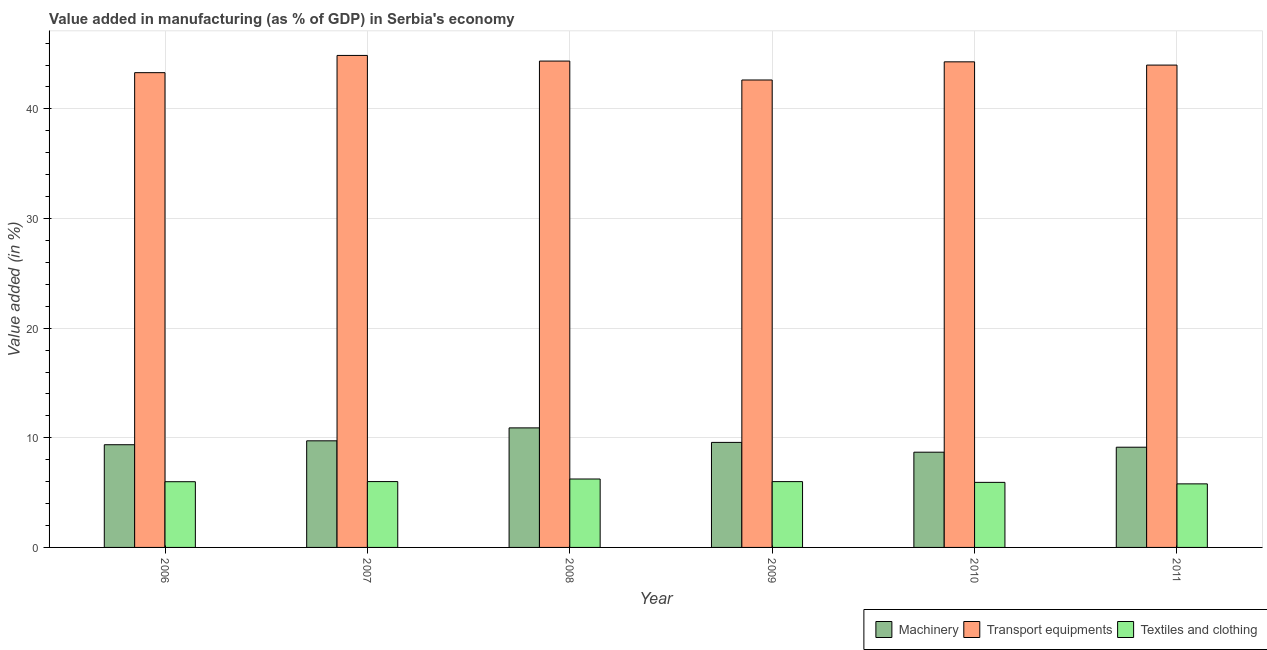How many different coloured bars are there?
Ensure brevity in your answer.  3. How many groups of bars are there?
Give a very brief answer. 6. In how many cases, is the number of bars for a given year not equal to the number of legend labels?
Offer a terse response. 0. What is the value added in manufacturing textile and clothing in 2006?
Your answer should be very brief. 6. Across all years, what is the maximum value added in manufacturing textile and clothing?
Your answer should be very brief. 6.24. Across all years, what is the minimum value added in manufacturing textile and clothing?
Offer a terse response. 5.8. In which year was the value added in manufacturing machinery maximum?
Make the answer very short. 2008. What is the total value added in manufacturing textile and clothing in the graph?
Your response must be concise. 35.98. What is the difference between the value added in manufacturing textile and clothing in 2006 and that in 2011?
Keep it short and to the point. 0.2. What is the difference between the value added in manufacturing transport equipments in 2006 and the value added in manufacturing textile and clothing in 2008?
Ensure brevity in your answer.  -1.06. What is the average value added in manufacturing textile and clothing per year?
Provide a succinct answer. 6. What is the ratio of the value added in manufacturing textile and clothing in 2010 to that in 2011?
Provide a succinct answer. 1.02. Is the difference between the value added in manufacturing textile and clothing in 2008 and 2011 greater than the difference between the value added in manufacturing machinery in 2008 and 2011?
Ensure brevity in your answer.  No. What is the difference between the highest and the second highest value added in manufacturing machinery?
Make the answer very short. 1.18. What is the difference between the highest and the lowest value added in manufacturing textile and clothing?
Give a very brief answer. 0.44. In how many years, is the value added in manufacturing textile and clothing greater than the average value added in manufacturing textile and clothing taken over all years?
Your response must be concise. 3. What does the 1st bar from the left in 2008 represents?
Make the answer very short. Machinery. What does the 3rd bar from the right in 2008 represents?
Give a very brief answer. Machinery. Is it the case that in every year, the sum of the value added in manufacturing machinery and value added in manufacturing transport equipments is greater than the value added in manufacturing textile and clothing?
Your answer should be compact. Yes. Are all the bars in the graph horizontal?
Ensure brevity in your answer.  No. Where does the legend appear in the graph?
Ensure brevity in your answer.  Bottom right. How are the legend labels stacked?
Ensure brevity in your answer.  Horizontal. What is the title of the graph?
Ensure brevity in your answer.  Value added in manufacturing (as % of GDP) in Serbia's economy. What is the label or title of the X-axis?
Ensure brevity in your answer.  Year. What is the label or title of the Y-axis?
Make the answer very short. Value added (in %). What is the Value added (in %) of Machinery in 2006?
Keep it short and to the point. 9.37. What is the Value added (in %) of Transport equipments in 2006?
Your answer should be very brief. 43.31. What is the Value added (in %) of Textiles and clothing in 2006?
Provide a succinct answer. 6. What is the Value added (in %) of Machinery in 2007?
Keep it short and to the point. 9.72. What is the Value added (in %) in Transport equipments in 2007?
Your response must be concise. 44.88. What is the Value added (in %) of Textiles and clothing in 2007?
Make the answer very short. 6.01. What is the Value added (in %) in Machinery in 2008?
Provide a succinct answer. 10.91. What is the Value added (in %) in Transport equipments in 2008?
Keep it short and to the point. 44.37. What is the Value added (in %) in Textiles and clothing in 2008?
Your answer should be very brief. 6.24. What is the Value added (in %) of Machinery in 2009?
Offer a terse response. 9.58. What is the Value added (in %) of Transport equipments in 2009?
Keep it short and to the point. 42.64. What is the Value added (in %) in Textiles and clothing in 2009?
Make the answer very short. 6. What is the Value added (in %) in Machinery in 2010?
Provide a short and direct response. 8.69. What is the Value added (in %) of Transport equipments in 2010?
Keep it short and to the point. 44.29. What is the Value added (in %) in Textiles and clothing in 2010?
Give a very brief answer. 5.94. What is the Value added (in %) in Machinery in 2011?
Give a very brief answer. 9.14. What is the Value added (in %) of Transport equipments in 2011?
Ensure brevity in your answer.  44. What is the Value added (in %) in Textiles and clothing in 2011?
Provide a short and direct response. 5.8. Across all years, what is the maximum Value added (in %) of Machinery?
Your response must be concise. 10.91. Across all years, what is the maximum Value added (in %) of Transport equipments?
Provide a succinct answer. 44.88. Across all years, what is the maximum Value added (in %) in Textiles and clothing?
Offer a terse response. 6.24. Across all years, what is the minimum Value added (in %) of Machinery?
Offer a very short reply. 8.69. Across all years, what is the minimum Value added (in %) in Transport equipments?
Provide a short and direct response. 42.64. Across all years, what is the minimum Value added (in %) in Textiles and clothing?
Ensure brevity in your answer.  5.8. What is the total Value added (in %) of Machinery in the graph?
Offer a very short reply. 57.41. What is the total Value added (in %) of Transport equipments in the graph?
Offer a very short reply. 263.48. What is the total Value added (in %) of Textiles and clothing in the graph?
Offer a very short reply. 35.98. What is the difference between the Value added (in %) of Machinery in 2006 and that in 2007?
Provide a short and direct response. -0.36. What is the difference between the Value added (in %) of Transport equipments in 2006 and that in 2007?
Provide a succinct answer. -1.57. What is the difference between the Value added (in %) of Textiles and clothing in 2006 and that in 2007?
Make the answer very short. -0.01. What is the difference between the Value added (in %) in Machinery in 2006 and that in 2008?
Your answer should be compact. -1.54. What is the difference between the Value added (in %) of Transport equipments in 2006 and that in 2008?
Give a very brief answer. -1.06. What is the difference between the Value added (in %) of Textiles and clothing in 2006 and that in 2008?
Provide a succinct answer. -0.25. What is the difference between the Value added (in %) of Machinery in 2006 and that in 2009?
Your answer should be very brief. -0.21. What is the difference between the Value added (in %) in Transport equipments in 2006 and that in 2009?
Your answer should be very brief. 0.67. What is the difference between the Value added (in %) of Textiles and clothing in 2006 and that in 2009?
Provide a short and direct response. -0.01. What is the difference between the Value added (in %) of Machinery in 2006 and that in 2010?
Your answer should be very brief. 0.68. What is the difference between the Value added (in %) in Transport equipments in 2006 and that in 2010?
Ensure brevity in your answer.  -0.99. What is the difference between the Value added (in %) in Textiles and clothing in 2006 and that in 2010?
Provide a short and direct response. 0.06. What is the difference between the Value added (in %) of Machinery in 2006 and that in 2011?
Provide a short and direct response. 0.23. What is the difference between the Value added (in %) of Transport equipments in 2006 and that in 2011?
Keep it short and to the point. -0.69. What is the difference between the Value added (in %) in Textiles and clothing in 2006 and that in 2011?
Ensure brevity in your answer.  0.2. What is the difference between the Value added (in %) of Machinery in 2007 and that in 2008?
Ensure brevity in your answer.  -1.18. What is the difference between the Value added (in %) of Transport equipments in 2007 and that in 2008?
Keep it short and to the point. 0.51. What is the difference between the Value added (in %) of Textiles and clothing in 2007 and that in 2008?
Ensure brevity in your answer.  -0.24. What is the difference between the Value added (in %) in Machinery in 2007 and that in 2009?
Your answer should be compact. 0.14. What is the difference between the Value added (in %) in Transport equipments in 2007 and that in 2009?
Your answer should be very brief. 2.24. What is the difference between the Value added (in %) in Textiles and clothing in 2007 and that in 2009?
Your response must be concise. 0. What is the difference between the Value added (in %) of Transport equipments in 2007 and that in 2010?
Offer a very short reply. 0.59. What is the difference between the Value added (in %) of Textiles and clothing in 2007 and that in 2010?
Offer a very short reply. 0.07. What is the difference between the Value added (in %) of Machinery in 2007 and that in 2011?
Ensure brevity in your answer.  0.58. What is the difference between the Value added (in %) of Transport equipments in 2007 and that in 2011?
Your answer should be very brief. 0.88. What is the difference between the Value added (in %) of Textiles and clothing in 2007 and that in 2011?
Ensure brevity in your answer.  0.21. What is the difference between the Value added (in %) in Machinery in 2008 and that in 2009?
Give a very brief answer. 1.33. What is the difference between the Value added (in %) of Transport equipments in 2008 and that in 2009?
Provide a short and direct response. 1.73. What is the difference between the Value added (in %) in Textiles and clothing in 2008 and that in 2009?
Your answer should be very brief. 0.24. What is the difference between the Value added (in %) in Machinery in 2008 and that in 2010?
Give a very brief answer. 2.22. What is the difference between the Value added (in %) in Transport equipments in 2008 and that in 2010?
Provide a short and direct response. 0.07. What is the difference between the Value added (in %) in Textiles and clothing in 2008 and that in 2010?
Your answer should be compact. 0.31. What is the difference between the Value added (in %) of Machinery in 2008 and that in 2011?
Your answer should be compact. 1.76. What is the difference between the Value added (in %) of Transport equipments in 2008 and that in 2011?
Offer a terse response. 0.37. What is the difference between the Value added (in %) in Textiles and clothing in 2008 and that in 2011?
Give a very brief answer. 0.44. What is the difference between the Value added (in %) in Machinery in 2009 and that in 2010?
Provide a succinct answer. 0.89. What is the difference between the Value added (in %) in Transport equipments in 2009 and that in 2010?
Keep it short and to the point. -1.66. What is the difference between the Value added (in %) in Textiles and clothing in 2009 and that in 2010?
Your answer should be compact. 0.07. What is the difference between the Value added (in %) in Machinery in 2009 and that in 2011?
Offer a terse response. 0.44. What is the difference between the Value added (in %) in Transport equipments in 2009 and that in 2011?
Make the answer very short. -1.36. What is the difference between the Value added (in %) in Textiles and clothing in 2009 and that in 2011?
Your answer should be compact. 0.21. What is the difference between the Value added (in %) of Machinery in 2010 and that in 2011?
Make the answer very short. -0.46. What is the difference between the Value added (in %) of Transport equipments in 2010 and that in 2011?
Your answer should be very brief. 0.3. What is the difference between the Value added (in %) of Textiles and clothing in 2010 and that in 2011?
Offer a very short reply. 0.14. What is the difference between the Value added (in %) of Machinery in 2006 and the Value added (in %) of Transport equipments in 2007?
Give a very brief answer. -35.51. What is the difference between the Value added (in %) in Machinery in 2006 and the Value added (in %) in Textiles and clothing in 2007?
Give a very brief answer. 3.36. What is the difference between the Value added (in %) of Transport equipments in 2006 and the Value added (in %) of Textiles and clothing in 2007?
Give a very brief answer. 37.3. What is the difference between the Value added (in %) of Machinery in 2006 and the Value added (in %) of Transport equipments in 2008?
Offer a very short reply. -35. What is the difference between the Value added (in %) of Machinery in 2006 and the Value added (in %) of Textiles and clothing in 2008?
Keep it short and to the point. 3.13. What is the difference between the Value added (in %) in Transport equipments in 2006 and the Value added (in %) in Textiles and clothing in 2008?
Give a very brief answer. 37.07. What is the difference between the Value added (in %) of Machinery in 2006 and the Value added (in %) of Transport equipments in 2009?
Offer a very short reply. -33.27. What is the difference between the Value added (in %) of Machinery in 2006 and the Value added (in %) of Textiles and clothing in 2009?
Your response must be concise. 3.36. What is the difference between the Value added (in %) in Transport equipments in 2006 and the Value added (in %) in Textiles and clothing in 2009?
Keep it short and to the point. 37.3. What is the difference between the Value added (in %) in Machinery in 2006 and the Value added (in %) in Transport equipments in 2010?
Offer a very short reply. -34.93. What is the difference between the Value added (in %) in Machinery in 2006 and the Value added (in %) in Textiles and clothing in 2010?
Provide a succinct answer. 3.43. What is the difference between the Value added (in %) in Transport equipments in 2006 and the Value added (in %) in Textiles and clothing in 2010?
Provide a succinct answer. 37.37. What is the difference between the Value added (in %) of Machinery in 2006 and the Value added (in %) of Transport equipments in 2011?
Make the answer very short. -34.63. What is the difference between the Value added (in %) in Machinery in 2006 and the Value added (in %) in Textiles and clothing in 2011?
Your answer should be compact. 3.57. What is the difference between the Value added (in %) of Transport equipments in 2006 and the Value added (in %) of Textiles and clothing in 2011?
Provide a succinct answer. 37.51. What is the difference between the Value added (in %) of Machinery in 2007 and the Value added (in %) of Transport equipments in 2008?
Give a very brief answer. -34.64. What is the difference between the Value added (in %) in Machinery in 2007 and the Value added (in %) in Textiles and clothing in 2008?
Make the answer very short. 3.48. What is the difference between the Value added (in %) in Transport equipments in 2007 and the Value added (in %) in Textiles and clothing in 2008?
Your answer should be compact. 38.64. What is the difference between the Value added (in %) in Machinery in 2007 and the Value added (in %) in Transport equipments in 2009?
Give a very brief answer. -32.92. What is the difference between the Value added (in %) in Machinery in 2007 and the Value added (in %) in Textiles and clothing in 2009?
Your answer should be compact. 3.72. What is the difference between the Value added (in %) in Transport equipments in 2007 and the Value added (in %) in Textiles and clothing in 2009?
Keep it short and to the point. 38.88. What is the difference between the Value added (in %) of Machinery in 2007 and the Value added (in %) of Transport equipments in 2010?
Provide a short and direct response. -34.57. What is the difference between the Value added (in %) in Machinery in 2007 and the Value added (in %) in Textiles and clothing in 2010?
Your response must be concise. 3.79. What is the difference between the Value added (in %) in Transport equipments in 2007 and the Value added (in %) in Textiles and clothing in 2010?
Give a very brief answer. 38.94. What is the difference between the Value added (in %) in Machinery in 2007 and the Value added (in %) in Transport equipments in 2011?
Keep it short and to the point. -34.27. What is the difference between the Value added (in %) of Machinery in 2007 and the Value added (in %) of Textiles and clothing in 2011?
Your answer should be compact. 3.93. What is the difference between the Value added (in %) in Transport equipments in 2007 and the Value added (in %) in Textiles and clothing in 2011?
Your response must be concise. 39.08. What is the difference between the Value added (in %) in Machinery in 2008 and the Value added (in %) in Transport equipments in 2009?
Your answer should be very brief. -31.73. What is the difference between the Value added (in %) in Machinery in 2008 and the Value added (in %) in Textiles and clothing in 2009?
Ensure brevity in your answer.  4.9. What is the difference between the Value added (in %) in Transport equipments in 2008 and the Value added (in %) in Textiles and clothing in 2009?
Your answer should be compact. 38.36. What is the difference between the Value added (in %) of Machinery in 2008 and the Value added (in %) of Transport equipments in 2010?
Keep it short and to the point. -33.39. What is the difference between the Value added (in %) in Machinery in 2008 and the Value added (in %) in Textiles and clothing in 2010?
Offer a very short reply. 4.97. What is the difference between the Value added (in %) in Transport equipments in 2008 and the Value added (in %) in Textiles and clothing in 2010?
Your answer should be compact. 38.43. What is the difference between the Value added (in %) of Machinery in 2008 and the Value added (in %) of Transport equipments in 2011?
Your answer should be very brief. -33.09. What is the difference between the Value added (in %) of Machinery in 2008 and the Value added (in %) of Textiles and clothing in 2011?
Your answer should be very brief. 5.11. What is the difference between the Value added (in %) of Transport equipments in 2008 and the Value added (in %) of Textiles and clothing in 2011?
Give a very brief answer. 38.57. What is the difference between the Value added (in %) of Machinery in 2009 and the Value added (in %) of Transport equipments in 2010?
Your answer should be very brief. -34.71. What is the difference between the Value added (in %) of Machinery in 2009 and the Value added (in %) of Textiles and clothing in 2010?
Provide a short and direct response. 3.64. What is the difference between the Value added (in %) of Transport equipments in 2009 and the Value added (in %) of Textiles and clothing in 2010?
Keep it short and to the point. 36.7. What is the difference between the Value added (in %) in Machinery in 2009 and the Value added (in %) in Transport equipments in 2011?
Your response must be concise. -34.42. What is the difference between the Value added (in %) in Machinery in 2009 and the Value added (in %) in Textiles and clothing in 2011?
Give a very brief answer. 3.78. What is the difference between the Value added (in %) in Transport equipments in 2009 and the Value added (in %) in Textiles and clothing in 2011?
Ensure brevity in your answer.  36.84. What is the difference between the Value added (in %) in Machinery in 2010 and the Value added (in %) in Transport equipments in 2011?
Offer a very short reply. -35.31. What is the difference between the Value added (in %) in Machinery in 2010 and the Value added (in %) in Textiles and clothing in 2011?
Keep it short and to the point. 2.89. What is the difference between the Value added (in %) in Transport equipments in 2010 and the Value added (in %) in Textiles and clothing in 2011?
Provide a short and direct response. 38.5. What is the average Value added (in %) in Machinery per year?
Offer a terse response. 9.57. What is the average Value added (in %) of Transport equipments per year?
Give a very brief answer. 43.91. What is the average Value added (in %) of Textiles and clothing per year?
Make the answer very short. 6. In the year 2006, what is the difference between the Value added (in %) of Machinery and Value added (in %) of Transport equipments?
Provide a short and direct response. -33.94. In the year 2006, what is the difference between the Value added (in %) of Machinery and Value added (in %) of Textiles and clothing?
Offer a very short reply. 3.37. In the year 2006, what is the difference between the Value added (in %) of Transport equipments and Value added (in %) of Textiles and clothing?
Provide a succinct answer. 37.31. In the year 2007, what is the difference between the Value added (in %) of Machinery and Value added (in %) of Transport equipments?
Make the answer very short. -35.16. In the year 2007, what is the difference between the Value added (in %) of Machinery and Value added (in %) of Textiles and clothing?
Make the answer very short. 3.72. In the year 2007, what is the difference between the Value added (in %) of Transport equipments and Value added (in %) of Textiles and clothing?
Your response must be concise. 38.87. In the year 2008, what is the difference between the Value added (in %) of Machinery and Value added (in %) of Transport equipments?
Provide a succinct answer. -33.46. In the year 2008, what is the difference between the Value added (in %) of Machinery and Value added (in %) of Textiles and clothing?
Ensure brevity in your answer.  4.66. In the year 2008, what is the difference between the Value added (in %) of Transport equipments and Value added (in %) of Textiles and clothing?
Your answer should be very brief. 38.12. In the year 2009, what is the difference between the Value added (in %) of Machinery and Value added (in %) of Transport equipments?
Provide a succinct answer. -33.06. In the year 2009, what is the difference between the Value added (in %) of Machinery and Value added (in %) of Textiles and clothing?
Ensure brevity in your answer.  3.58. In the year 2009, what is the difference between the Value added (in %) of Transport equipments and Value added (in %) of Textiles and clothing?
Provide a short and direct response. 36.64. In the year 2010, what is the difference between the Value added (in %) of Machinery and Value added (in %) of Transport equipments?
Your response must be concise. -35.61. In the year 2010, what is the difference between the Value added (in %) in Machinery and Value added (in %) in Textiles and clothing?
Ensure brevity in your answer.  2.75. In the year 2010, what is the difference between the Value added (in %) of Transport equipments and Value added (in %) of Textiles and clothing?
Provide a succinct answer. 38.36. In the year 2011, what is the difference between the Value added (in %) in Machinery and Value added (in %) in Transport equipments?
Offer a very short reply. -34.86. In the year 2011, what is the difference between the Value added (in %) of Machinery and Value added (in %) of Textiles and clothing?
Offer a terse response. 3.34. In the year 2011, what is the difference between the Value added (in %) of Transport equipments and Value added (in %) of Textiles and clothing?
Provide a short and direct response. 38.2. What is the ratio of the Value added (in %) in Machinery in 2006 to that in 2007?
Ensure brevity in your answer.  0.96. What is the ratio of the Value added (in %) of Textiles and clothing in 2006 to that in 2007?
Make the answer very short. 1. What is the ratio of the Value added (in %) of Machinery in 2006 to that in 2008?
Your answer should be very brief. 0.86. What is the ratio of the Value added (in %) of Transport equipments in 2006 to that in 2008?
Your answer should be compact. 0.98. What is the ratio of the Value added (in %) of Textiles and clothing in 2006 to that in 2008?
Give a very brief answer. 0.96. What is the ratio of the Value added (in %) in Machinery in 2006 to that in 2009?
Make the answer very short. 0.98. What is the ratio of the Value added (in %) in Transport equipments in 2006 to that in 2009?
Provide a short and direct response. 1.02. What is the ratio of the Value added (in %) in Textiles and clothing in 2006 to that in 2009?
Your response must be concise. 1. What is the ratio of the Value added (in %) of Machinery in 2006 to that in 2010?
Your answer should be very brief. 1.08. What is the ratio of the Value added (in %) of Transport equipments in 2006 to that in 2010?
Offer a terse response. 0.98. What is the ratio of the Value added (in %) in Textiles and clothing in 2006 to that in 2010?
Make the answer very short. 1.01. What is the ratio of the Value added (in %) of Machinery in 2006 to that in 2011?
Offer a very short reply. 1.02. What is the ratio of the Value added (in %) of Transport equipments in 2006 to that in 2011?
Your answer should be compact. 0.98. What is the ratio of the Value added (in %) in Textiles and clothing in 2006 to that in 2011?
Your answer should be compact. 1.03. What is the ratio of the Value added (in %) of Machinery in 2007 to that in 2008?
Your response must be concise. 0.89. What is the ratio of the Value added (in %) of Transport equipments in 2007 to that in 2008?
Make the answer very short. 1.01. What is the ratio of the Value added (in %) in Textiles and clothing in 2007 to that in 2008?
Keep it short and to the point. 0.96. What is the ratio of the Value added (in %) in Machinery in 2007 to that in 2009?
Give a very brief answer. 1.01. What is the ratio of the Value added (in %) in Transport equipments in 2007 to that in 2009?
Offer a terse response. 1.05. What is the ratio of the Value added (in %) of Textiles and clothing in 2007 to that in 2009?
Offer a terse response. 1. What is the ratio of the Value added (in %) of Machinery in 2007 to that in 2010?
Provide a succinct answer. 1.12. What is the ratio of the Value added (in %) in Transport equipments in 2007 to that in 2010?
Your answer should be compact. 1.01. What is the ratio of the Value added (in %) in Textiles and clothing in 2007 to that in 2010?
Give a very brief answer. 1.01. What is the ratio of the Value added (in %) of Machinery in 2007 to that in 2011?
Your answer should be compact. 1.06. What is the ratio of the Value added (in %) in Transport equipments in 2007 to that in 2011?
Ensure brevity in your answer.  1.02. What is the ratio of the Value added (in %) of Textiles and clothing in 2007 to that in 2011?
Offer a terse response. 1.04. What is the ratio of the Value added (in %) of Machinery in 2008 to that in 2009?
Ensure brevity in your answer.  1.14. What is the ratio of the Value added (in %) of Transport equipments in 2008 to that in 2009?
Make the answer very short. 1.04. What is the ratio of the Value added (in %) in Textiles and clothing in 2008 to that in 2009?
Your response must be concise. 1.04. What is the ratio of the Value added (in %) of Machinery in 2008 to that in 2010?
Ensure brevity in your answer.  1.26. What is the ratio of the Value added (in %) of Transport equipments in 2008 to that in 2010?
Provide a short and direct response. 1. What is the ratio of the Value added (in %) in Textiles and clothing in 2008 to that in 2010?
Offer a terse response. 1.05. What is the ratio of the Value added (in %) of Machinery in 2008 to that in 2011?
Provide a succinct answer. 1.19. What is the ratio of the Value added (in %) of Transport equipments in 2008 to that in 2011?
Your response must be concise. 1.01. What is the ratio of the Value added (in %) in Textiles and clothing in 2008 to that in 2011?
Keep it short and to the point. 1.08. What is the ratio of the Value added (in %) of Machinery in 2009 to that in 2010?
Your response must be concise. 1.1. What is the ratio of the Value added (in %) in Transport equipments in 2009 to that in 2010?
Your answer should be very brief. 0.96. What is the ratio of the Value added (in %) of Textiles and clothing in 2009 to that in 2010?
Make the answer very short. 1.01. What is the ratio of the Value added (in %) of Machinery in 2009 to that in 2011?
Offer a very short reply. 1.05. What is the ratio of the Value added (in %) of Transport equipments in 2009 to that in 2011?
Provide a short and direct response. 0.97. What is the ratio of the Value added (in %) in Textiles and clothing in 2009 to that in 2011?
Your response must be concise. 1.04. What is the ratio of the Value added (in %) in Machinery in 2010 to that in 2011?
Ensure brevity in your answer.  0.95. What is the ratio of the Value added (in %) of Transport equipments in 2010 to that in 2011?
Provide a short and direct response. 1.01. What is the ratio of the Value added (in %) in Textiles and clothing in 2010 to that in 2011?
Give a very brief answer. 1.02. What is the difference between the highest and the second highest Value added (in %) of Machinery?
Provide a short and direct response. 1.18. What is the difference between the highest and the second highest Value added (in %) in Transport equipments?
Offer a very short reply. 0.51. What is the difference between the highest and the second highest Value added (in %) of Textiles and clothing?
Your answer should be compact. 0.24. What is the difference between the highest and the lowest Value added (in %) of Machinery?
Your response must be concise. 2.22. What is the difference between the highest and the lowest Value added (in %) of Transport equipments?
Give a very brief answer. 2.24. What is the difference between the highest and the lowest Value added (in %) of Textiles and clothing?
Your answer should be compact. 0.44. 